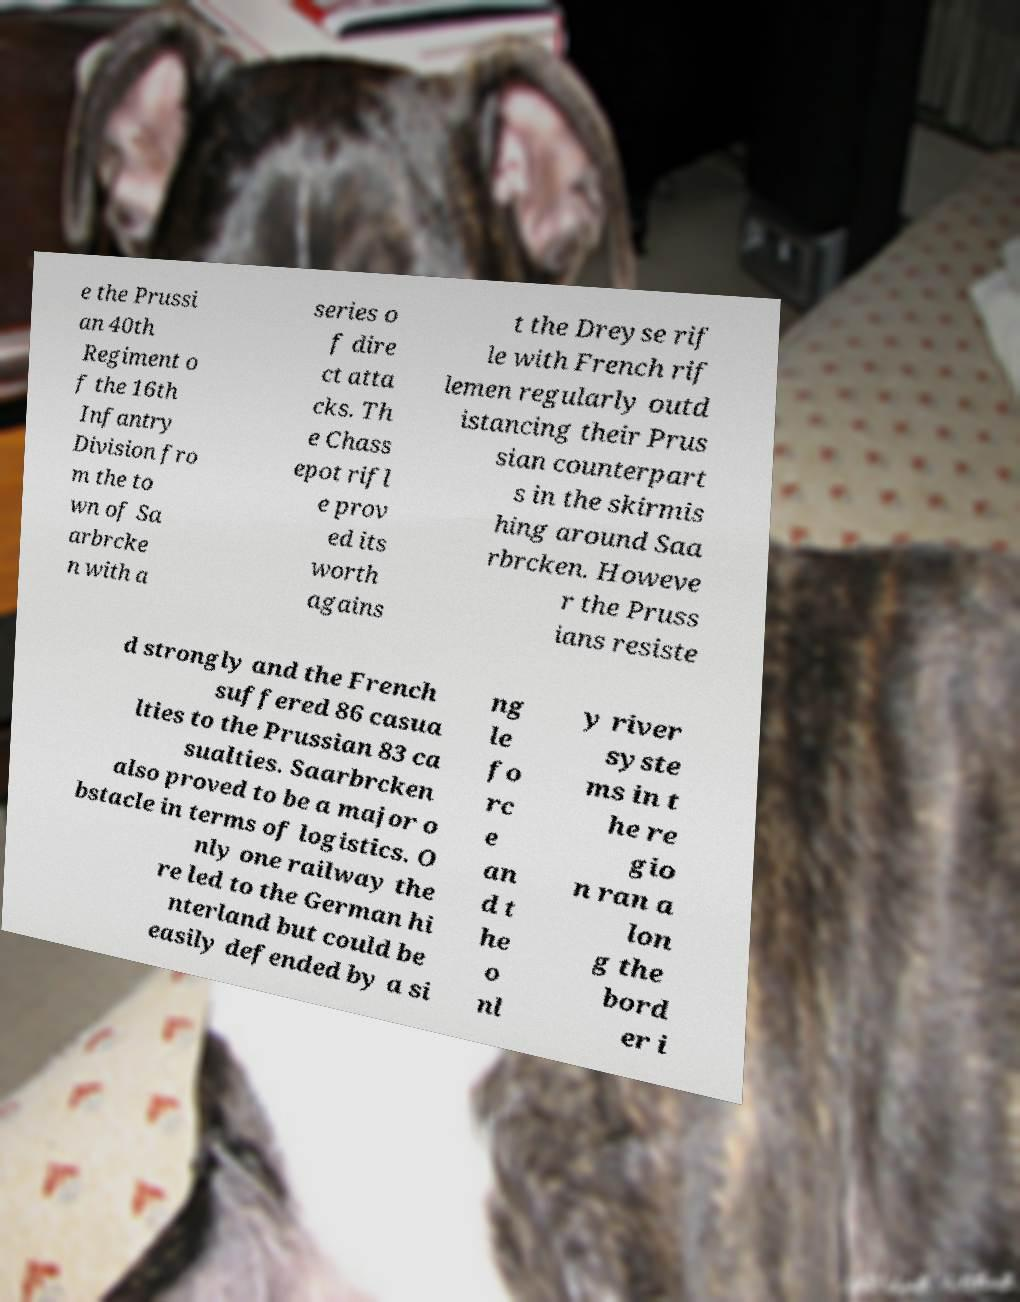What messages or text are displayed in this image? I need them in a readable, typed format. e the Prussi an 40th Regiment o f the 16th Infantry Division fro m the to wn of Sa arbrcke n with a series o f dire ct atta cks. Th e Chass epot rifl e prov ed its worth agains t the Dreyse rif le with French rif lemen regularly outd istancing their Prus sian counterpart s in the skirmis hing around Saa rbrcken. Howeve r the Pruss ians resiste d strongly and the French suffered 86 casua lties to the Prussian 83 ca sualties. Saarbrcken also proved to be a major o bstacle in terms of logistics. O nly one railway the re led to the German hi nterland but could be easily defended by a si ng le fo rc e an d t he o nl y river syste ms in t he re gio n ran a lon g the bord er i 